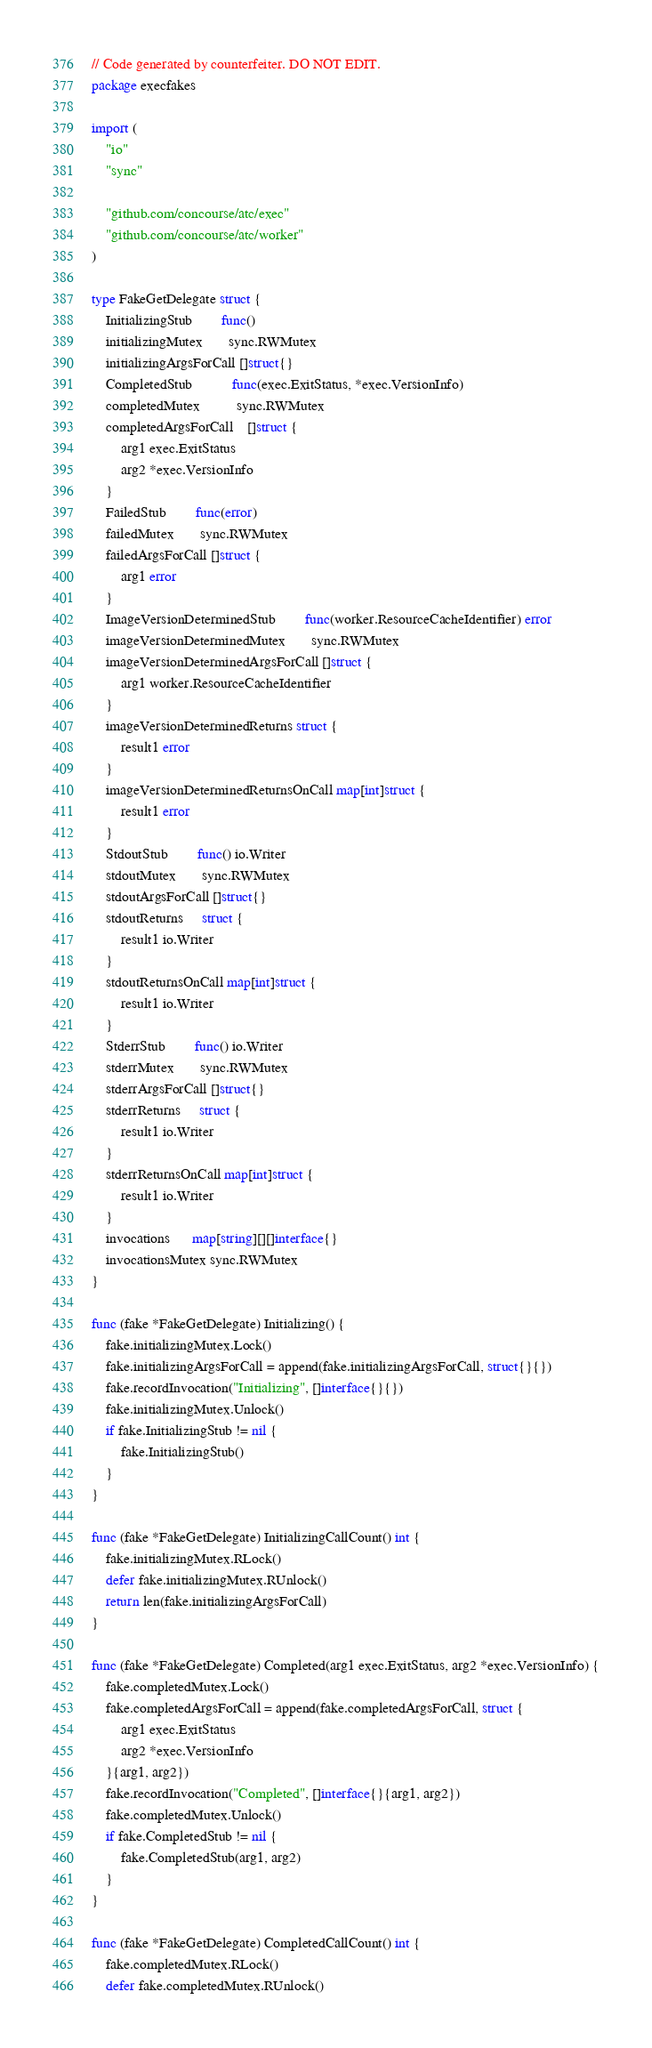Convert code to text. <code><loc_0><loc_0><loc_500><loc_500><_Go_>// Code generated by counterfeiter. DO NOT EDIT.
package execfakes

import (
	"io"
	"sync"

	"github.com/concourse/atc/exec"
	"github.com/concourse/atc/worker"
)

type FakeGetDelegate struct {
	InitializingStub        func()
	initializingMutex       sync.RWMutex
	initializingArgsForCall []struct{}
	CompletedStub           func(exec.ExitStatus, *exec.VersionInfo)
	completedMutex          sync.RWMutex
	completedArgsForCall    []struct {
		arg1 exec.ExitStatus
		arg2 *exec.VersionInfo
	}
	FailedStub        func(error)
	failedMutex       sync.RWMutex
	failedArgsForCall []struct {
		arg1 error
	}
	ImageVersionDeterminedStub        func(worker.ResourceCacheIdentifier) error
	imageVersionDeterminedMutex       sync.RWMutex
	imageVersionDeterminedArgsForCall []struct {
		arg1 worker.ResourceCacheIdentifier
	}
	imageVersionDeterminedReturns struct {
		result1 error
	}
	imageVersionDeterminedReturnsOnCall map[int]struct {
		result1 error
	}
	StdoutStub        func() io.Writer
	stdoutMutex       sync.RWMutex
	stdoutArgsForCall []struct{}
	stdoutReturns     struct {
		result1 io.Writer
	}
	stdoutReturnsOnCall map[int]struct {
		result1 io.Writer
	}
	StderrStub        func() io.Writer
	stderrMutex       sync.RWMutex
	stderrArgsForCall []struct{}
	stderrReturns     struct {
		result1 io.Writer
	}
	stderrReturnsOnCall map[int]struct {
		result1 io.Writer
	}
	invocations      map[string][][]interface{}
	invocationsMutex sync.RWMutex
}

func (fake *FakeGetDelegate) Initializing() {
	fake.initializingMutex.Lock()
	fake.initializingArgsForCall = append(fake.initializingArgsForCall, struct{}{})
	fake.recordInvocation("Initializing", []interface{}{})
	fake.initializingMutex.Unlock()
	if fake.InitializingStub != nil {
		fake.InitializingStub()
	}
}

func (fake *FakeGetDelegate) InitializingCallCount() int {
	fake.initializingMutex.RLock()
	defer fake.initializingMutex.RUnlock()
	return len(fake.initializingArgsForCall)
}

func (fake *FakeGetDelegate) Completed(arg1 exec.ExitStatus, arg2 *exec.VersionInfo) {
	fake.completedMutex.Lock()
	fake.completedArgsForCall = append(fake.completedArgsForCall, struct {
		arg1 exec.ExitStatus
		arg2 *exec.VersionInfo
	}{arg1, arg2})
	fake.recordInvocation("Completed", []interface{}{arg1, arg2})
	fake.completedMutex.Unlock()
	if fake.CompletedStub != nil {
		fake.CompletedStub(arg1, arg2)
	}
}

func (fake *FakeGetDelegate) CompletedCallCount() int {
	fake.completedMutex.RLock()
	defer fake.completedMutex.RUnlock()</code> 